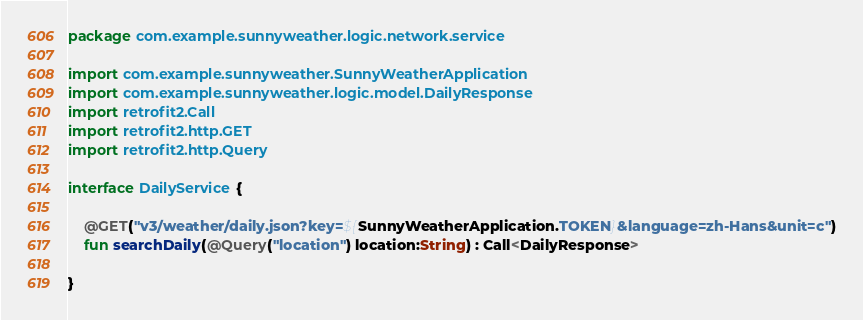Convert code to text. <code><loc_0><loc_0><loc_500><loc_500><_Kotlin_>package com.example.sunnyweather.logic.network.service

import com.example.sunnyweather.SunnyWeatherApplication
import com.example.sunnyweather.logic.model.DailyResponse
import retrofit2.Call
import retrofit2.http.GET
import retrofit2.http.Query

interface DailyService {

    @GET("v3/weather/daily.json?key=${SunnyWeatherApplication.TOKEN}&language=zh-Hans&unit=c")
    fun searchDaily(@Query("location") location:String) : Call<DailyResponse>

}</code> 